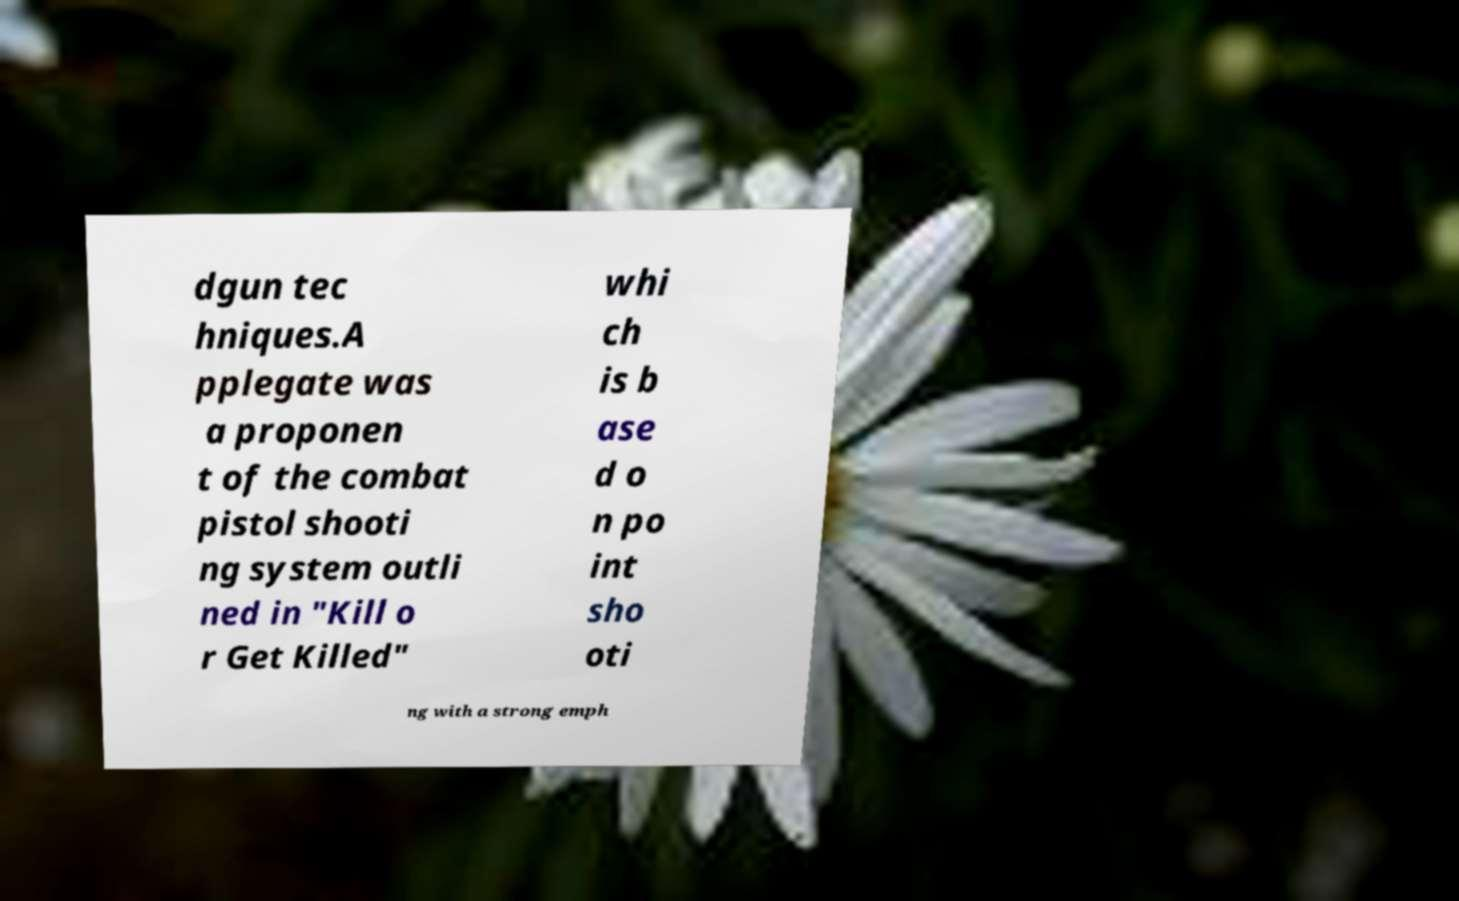Please read and relay the text visible in this image. What does it say? dgun tec hniques.A pplegate was a proponen t of the combat pistol shooti ng system outli ned in "Kill o r Get Killed" whi ch is b ase d o n po int sho oti ng with a strong emph 